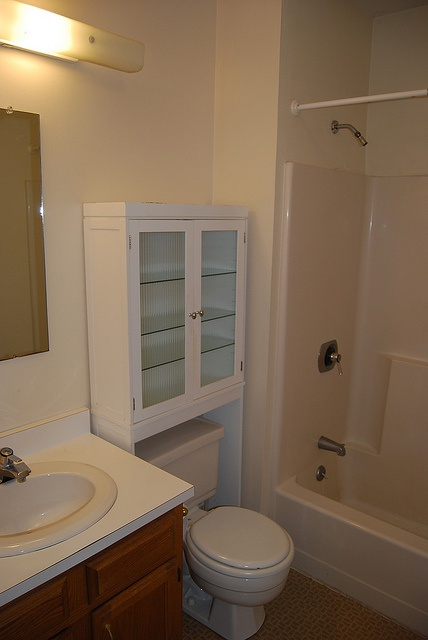Describe the objects in this image and their specific colors. I can see toilet in tan, gray, and black tones and sink in tan, gray, and darkgray tones in this image. 